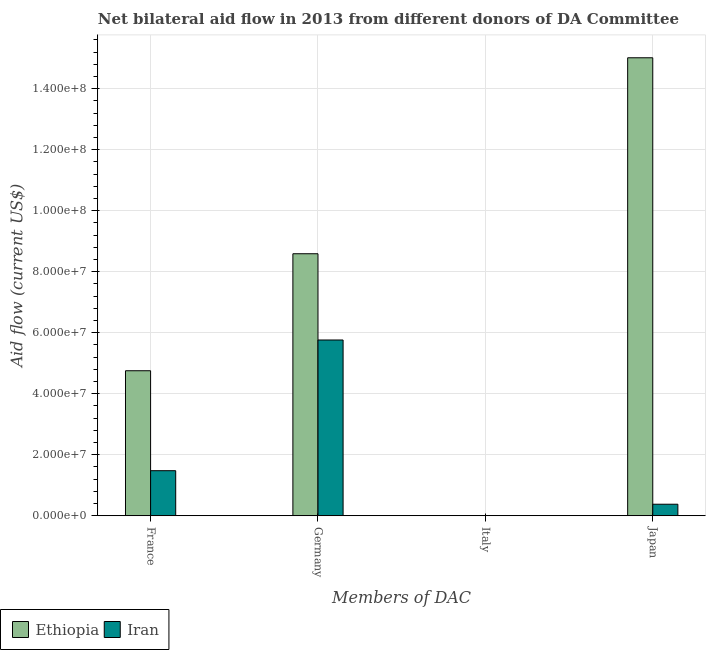Are the number of bars per tick equal to the number of legend labels?
Offer a very short reply. No. Are the number of bars on each tick of the X-axis equal?
Offer a terse response. No. How many bars are there on the 3rd tick from the left?
Keep it short and to the point. 1. What is the label of the 4th group of bars from the left?
Ensure brevity in your answer.  Japan. What is the amount of aid given by japan in Ethiopia?
Offer a very short reply. 1.50e+08. Across all countries, what is the maximum amount of aid given by japan?
Give a very brief answer. 1.50e+08. Across all countries, what is the minimum amount of aid given by germany?
Offer a terse response. 5.76e+07. In which country was the amount of aid given by germany maximum?
Provide a short and direct response. Ethiopia. What is the total amount of aid given by france in the graph?
Make the answer very short. 6.23e+07. What is the difference between the amount of aid given by japan in Iran and that in Ethiopia?
Ensure brevity in your answer.  -1.46e+08. What is the difference between the amount of aid given by france in Ethiopia and the amount of aid given by germany in Iran?
Provide a succinct answer. -1.01e+07. What is the average amount of aid given by germany per country?
Offer a very short reply. 7.18e+07. What is the difference between the amount of aid given by japan and amount of aid given by italy in Iran?
Make the answer very short. 3.72e+06. In how many countries, is the amount of aid given by japan greater than 60000000 US$?
Your answer should be compact. 1. What is the ratio of the amount of aid given by germany in Iran to that in Ethiopia?
Provide a succinct answer. 0.67. Is the difference between the amount of aid given by france in Ethiopia and Iran greater than the difference between the amount of aid given by japan in Ethiopia and Iran?
Provide a succinct answer. No. What is the difference between the highest and the second highest amount of aid given by germany?
Your answer should be very brief. 2.83e+07. What is the difference between the highest and the lowest amount of aid given by germany?
Your answer should be compact. 2.83e+07. In how many countries, is the amount of aid given by italy greater than the average amount of aid given by italy taken over all countries?
Offer a very short reply. 1. Is the sum of the amount of aid given by japan in Ethiopia and Iran greater than the maximum amount of aid given by italy across all countries?
Your answer should be very brief. Yes. Are all the bars in the graph horizontal?
Keep it short and to the point. No. Are the values on the major ticks of Y-axis written in scientific E-notation?
Your answer should be compact. Yes. Does the graph contain any zero values?
Offer a very short reply. Yes. Where does the legend appear in the graph?
Give a very brief answer. Bottom left. How are the legend labels stacked?
Offer a very short reply. Horizontal. What is the title of the graph?
Make the answer very short. Net bilateral aid flow in 2013 from different donors of DA Committee. What is the label or title of the X-axis?
Provide a succinct answer. Members of DAC. What is the Aid flow (current US$) in Ethiopia in France?
Keep it short and to the point. 4.75e+07. What is the Aid flow (current US$) of Iran in France?
Your answer should be compact. 1.48e+07. What is the Aid flow (current US$) in Ethiopia in Germany?
Give a very brief answer. 8.59e+07. What is the Aid flow (current US$) of Iran in Germany?
Offer a terse response. 5.76e+07. What is the Aid flow (current US$) of Ethiopia in Italy?
Give a very brief answer. 0. What is the Aid flow (current US$) in Iran in Italy?
Your answer should be compact. 7.00e+04. What is the Aid flow (current US$) in Ethiopia in Japan?
Provide a succinct answer. 1.50e+08. What is the Aid flow (current US$) in Iran in Japan?
Your answer should be very brief. 3.79e+06. Across all Members of DAC, what is the maximum Aid flow (current US$) in Ethiopia?
Keep it short and to the point. 1.50e+08. Across all Members of DAC, what is the maximum Aid flow (current US$) of Iran?
Keep it short and to the point. 5.76e+07. Across all Members of DAC, what is the minimum Aid flow (current US$) in Iran?
Your answer should be compact. 7.00e+04. What is the total Aid flow (current US$) of Ethiopia in the graph?
Your answer should be very brief. 2.84e+08. What is the total Aid flow (current US$) of Iran in the graph?
Offer a terse response. 7.63e+07. What is the difference between the Aid flow (current US$) of Ethiopia in France and that in Germany?
Provide a short and direct response. -3.84e+07. What is the difference between the Aid flow (current US$) of Iran in France and that in Germany?
Your answer should be very brief. -4.28e+07. What is the difference between the Aid flow (current US$) of Iran in France and that in Italy?
Your response must be concise. 1.47e+07. What is the difference between the Aid flow (current US$) of Ethiopia in France and that in Japan?
Your answer should be compact. -1.03e+08. What is the difference between the Aid flow (current US$) in Iran in France and that in Japan?
Your response must be concise. 1.10e+07. What is the difference between the Aid flow (current US$) of Iran in Germany and that in Italy?
Ensure brevity in your answer.  5.76e+07. What is the difference between the Aid flow (current US$) of Ethiopia in Germany and that in Japan?
Your answer should be very brief. -6.42e+07. What is the difference between the Aid flow (current US$) of Iran in Germany and that in Japan?
Your response must be concise. 5.38e+07. What is the difference between the Aid flow (current US$) in Iran in Italy and that in Japan?
Provide a succinct answer. -3.72e+06. What is the difference between the Aid flow (current US$) in Ethiopia in France and the Aid flow (current US$) in Iran in Germany?
Ensure brevity in your answer.  -1.01e+07. What is the difference between the Aid flow (current US$) of Ethiopia in France and the Aid flow (current US$) of Iran in Italy?
Keep it short and to the point. 4.75e+07. What is the difference between the Aid flow (current US$) in Ethiopia in France and the Aid flow (current US$) in Iran in Japan?
Your answer should be compact. 4.38e+07. What is the difference between the Aid flow (current US$) in Ethiopia in Germany and the Aid flow (current US$) in Iran in Italy?
Keep it short and to the point. 8.58e+07. What is the difference between the Aid flow (current US$) in Ethiopia in Germany and the Aid flow (current US$) in Iran in Japan?
Offer a terse response. 8.21e+07. What is the average Aid flow (current US$) in Ethiopia per Members of DAC?
Make the answer very short. 7.09e+07. What is the average Aid flow (current US$) in Iran per Members of DAC?
Your answer should be very brief. 1.91e+07. What is the difference between the Aid flow (current US$) of Ethiopia and Aid flow (current US$) of Iran in France?
Your response must be concise. 3.28e+07. What is the difference between the Aid flow (current US$) of Ethiopia and Aid flow (current US$) of Iran in Germany?
Your response must be concise. 2.83e+07. What is the difference between the Aid flow (current US$) in Ethiopia and Aid flow (current US$) in Iran in Japan?
Your answer should be very brief. 1.46e+08. What is the ratio of the Aid flow (current US$) in Ethiopia in France to that in Germany?
Offer a very short reply. 0.55. What is the ratio of the Aid flow (current US$) in Iran in France to that in Germany?
Your answer should be very brief. 0.26. What is the ratio of the Aid flow (current US$) in Iran in France to that in Italy?
Offer a terse response. 211.14. What is the ratio of the Aid flow (current US$) of Ethiopia in France to that in Japan?
Ensure brevity in your answer.  0.32. What is the ratio of the Aid flow (current US$) in Iran in France to that in Japan?
Keep it short and to the point. 3.9. What is the ratio of the Aid flow (current US$) in Iran in Germany to that in Italy?
Make the answer very short. 823.14. What is the ratio of the Aid flow (current US$) of Ethiopia in Germany to that in Japan?
Your response must be concise. 0.57. What is the ratio of the Aid flow (current US$) of Iran in Germany to that in Japan?
Make the answer very short. 15.2. What is the ratio of the Aid flow (current US$) of Iran in Italy to that in Japan?
Make the answer very short. 0.02. What is the difference between the highest and the second highest Aid flow (current US$) of Ethiopia?
Give a very brief answer. 6.42e+07. What is the difference between the highest and the second highest Aid flow (current US$) of Iran?
Your answer should be very brief. 4.28e+07. What is the difference between the highest and the lowest Aid flow (current US$) of Ethiopia?
Your answer should be very brief. 1.50e+08. What is the difference between the highest and the lowest Aid flow (current US$) of Iran?
Give a very brief answer. 5.76e+07. 